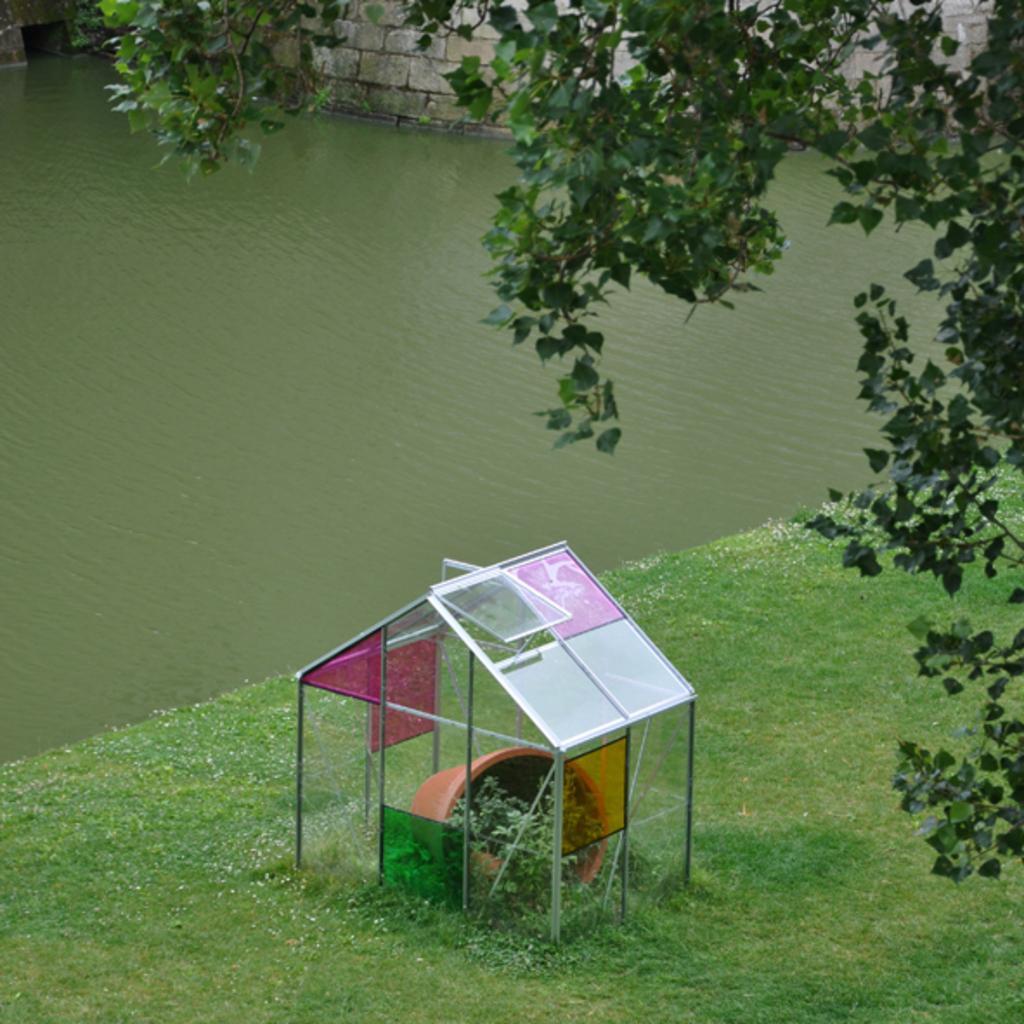Could you give a brief overview of what you see in this image? In this image in the center there is one house flower pot, plant and at the bottom there is grass. And in the background there is a lake, wall. On the right side there is a tree. 